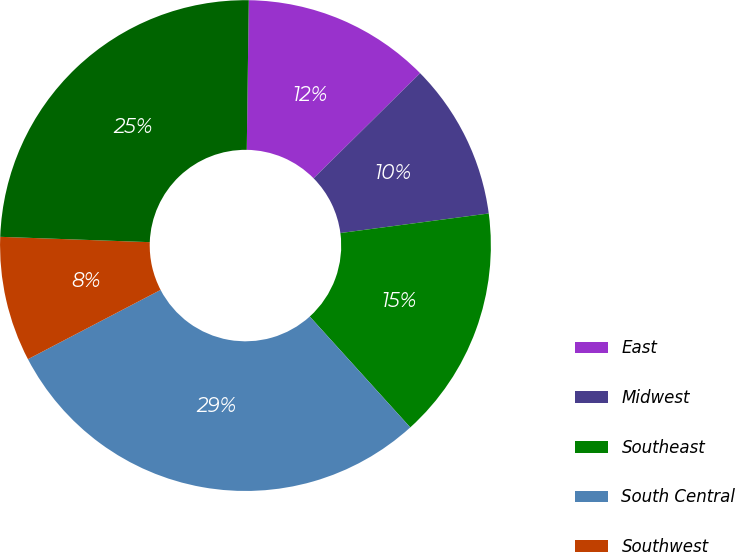Convert chart. <chart><loc_0><loc_0><loc_500><loc_500><pie_chart><fcel>East<fcel>Midwest<fcel>Southeast<fcel>South Central<fcel>Southwest<fcel>West<nl><fcel>12.39%<fcel>10.31%<fcel>15.37%<fcel>29.06%<fcel>8.23%<fcel>24.65%<nl></chart> 